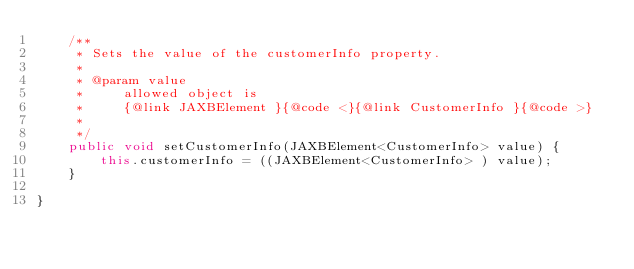<code> <loc_0><loc_0><loc_500><loc_500><_Java_>    /**
     * Sets the value of the customerInfo property.
     * 
     * @param value
     *     allowed object is
     *     {@link JAXBElement }{@code <}{@link CustomerInfo }{@code >}
     *     
     */
    public void setCustomerInfo(JAXBElement<CustomerInfo> value) {
        this.customerInfo = ((JAXBElement<CustomerInfo> ) value);
    }

}
</code> 